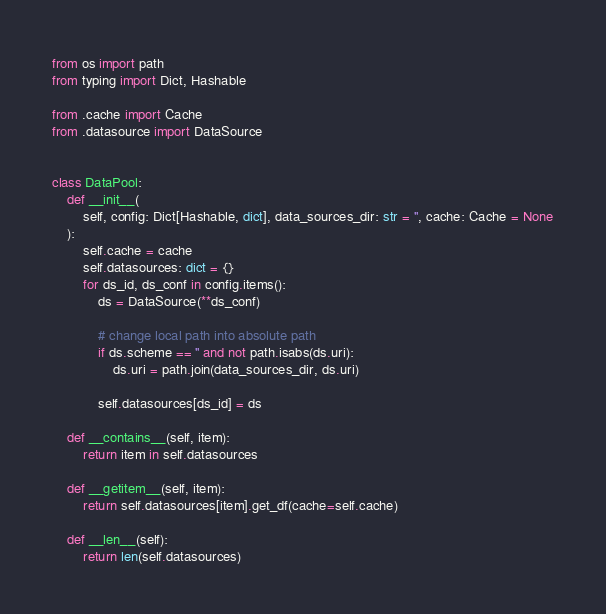<code> <loc_0><loc_0><loc_500><loc_500><_Python_>from os import path
from typing import Dict, Hashable

from .cache import Cache
from .datasource import DataSource


class DataPool:
    def __init__(
        self, config: Dict[Hashable, dict], data_sources_dir: str = '', cache: Cache = None
    ):
        self.cache = cache
        self.datasources: dict = {}
        for ds_id, ds_conf in config.items():
            ds = DataSource(**ds_conf)

            # change local path into absolute path
            if ds.scheme == '' and not path.isabs(ds.uri):
                ds.uri = path.join(data_sources_dir, ds.uri)

            self.datasources[ds_id] = ds

    def __contains__(self, item):
        return item in self.datasources

    def __getitem__(self, item):
        return self.datasources[item].get_df(cache=self.cache)

    def __len__(self):
        return len(self.datasources)
</code> 